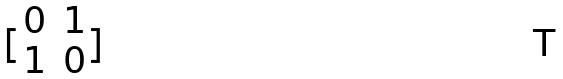Convert formula to latex. <formula><loc_0><loc_0><loc_500><loc_500>[ \begin{matrix} 0 & 1 \\ 1 & 0 \end{matrix} ]</formula> 